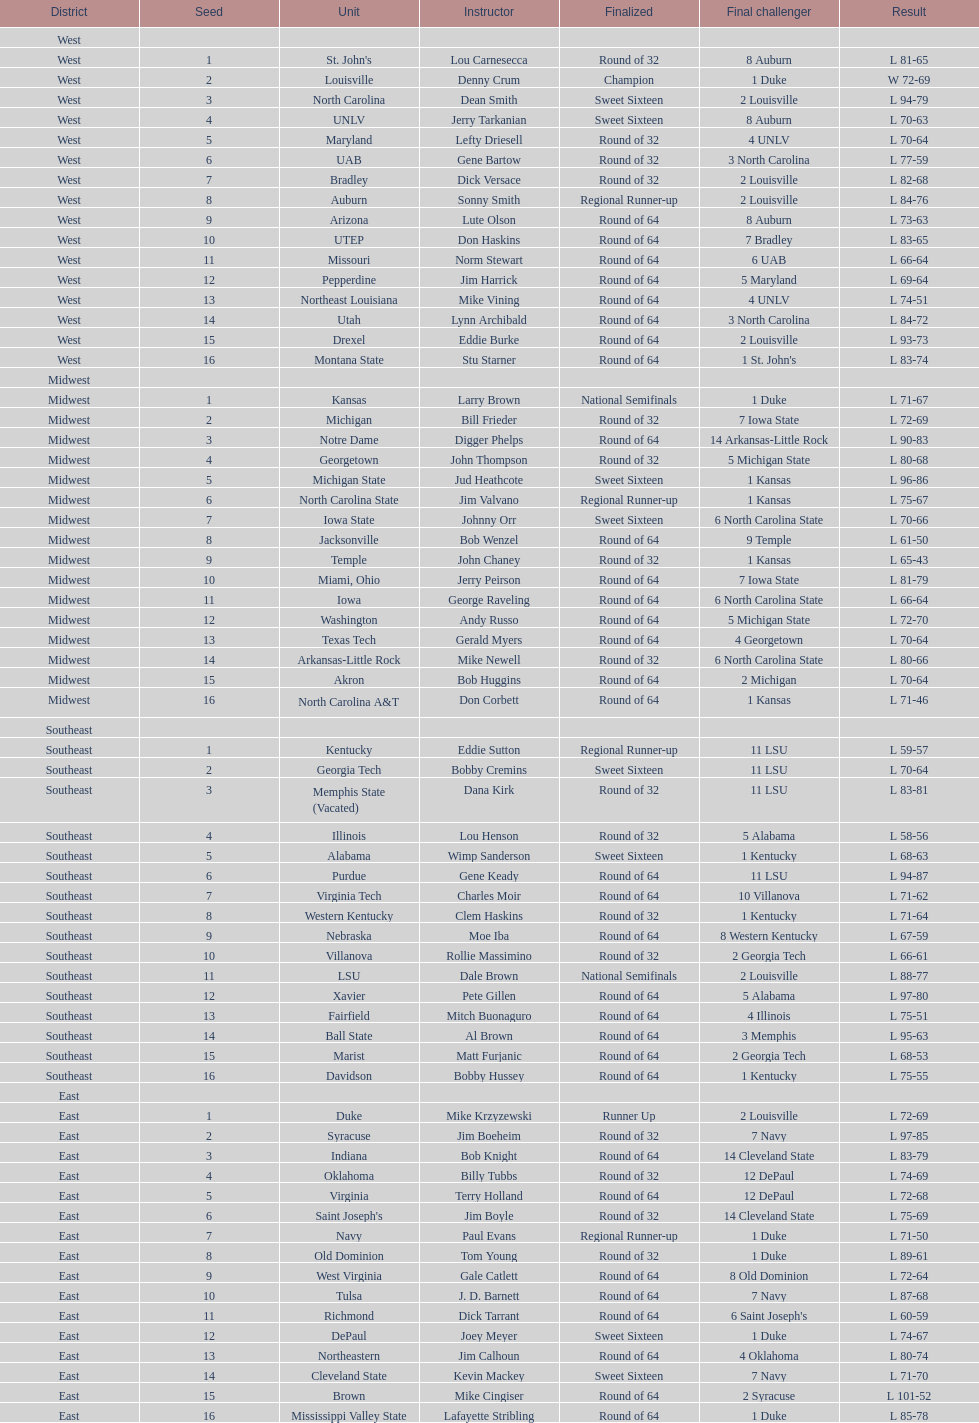Write the full table. {'header': ['District', 'Seed', 'Unit', 'Instructor', 'Finalized', 'Final challenger', 'Result'], 'rows': [['West', '', '', '', '', '', ''], ['West', '1', "St. John's", 'Lou Carnesecca', 'Round of 32', '8 Auburn', 'L 81-65'], ['West', '2', 'Louisville', 'Denny Crum', 'Champion', '1 Duke', 'W 72-69'], ['West', '3', 'North Carolina', 'Dean Smith', 'Sweet Sixteen', '2 Louisville', 'L 94-79'], ['West', '4', 'UNLV', 'Jerry Tarkanian', 'Sweet Sixteen', '8 Auburn', 'L 70-63'], ['West', '5', 'Maryland', 'Lefty Driesell', 'Round of 32', '4 UNLV', 'L 70-64'], ['West', '6', 'UAB', 'Gene Bartow', 'Round of 32', '3 North Carolina', 'L 77-59'], ['West', '7', 'Bradley', 'Dick Versace', 'Round of 32', '2 Louisville', 'L 82-68'], ['West', '8', 'Auburn', 'Sonny Smith', 'Regional Runner-up', '2 Louisville', 'L 84-76'], ['West', '9', 'Arizona', 'Lute Olson', 'Round of 64', '8 Auburn', 'L 73-63'], ['West', '10', 'UTEP', 'Don Haskins', 'Round of 64', '7 Bradley', 'L 83-65'], ['West', '11', 'Missouri', 'Norm Stewart', 'Round of 64', '6 UAB', 'L 66-64'], ['West', '12', 'Pepperdine', 'Jim Harrick', 'Round of 64', '5 Maryland', 'L 69-64'], ['West', '13', 'Northeast Louisiana', 'Mike Vining', 'Round of 64', '4 UNLV', 'L 74-51'], ['West', '14', 'Utah', 'Lynn Archibald', 'Round of 64', '3 North Carolina', 'L 84-72'], ['West', '15', 'Drexel', 'Eddie Burke', 'Round of 64', '2 Louisville', 'L 93-73'], ['West', '16', 'Montana State', 'Stu Starner', 'Round of 64', "1 St. John's", 'L 83-74'], ['Midwest', '', '', '', '', '', ''], ['Midwest', '1', 'Kansas', 'Larry Brown', 'National Semifinals', '1 Duke', 'L 71-67'], ['Midwest', '2', 'Michigan', 'Bill Frieder', 'Round of 32', '7 Iowa State', 'L 72-69'], ['Midwest', '3', 'Notre Dame', 'Digger Phelps', 'Round of 64', '14 Arkansas-Little Rock', 'L 90-83'], ['Midwest', '4', 'Georgetown', 'John Thompson', 'Round of 32', '5 Michigan State', 'L 80-68'], ['Midwest', '5', 'Michigan State', 'Jud Heathcote', 'Sweet Sixteen', '1 Kansas', 'L 96-86'], ['Midwest', '6', 'North Carolina State', 'Jim Valvano', 'Regional Runner-up', '1 Kansas', 'L 75-67'], ['Midwest', '7', 'Iowa State', 'Johnny Orr', 'Sweet Sixteen', '6 North Carolina State', 'L 70-66'], ['Midwest', '8', 'Jacksonville', 'Bob Wenzel', 'Round of 64', '9 Temple', 'L 61-50'], ['Midwest', '9', 'Temple', 'John Chaney', 'Round of 32', '1 Kansas', 'L 65-43'], ['Midwest', '10', 'Miami, Ohio', 'Jerry Peirson', 'Round of 64', '7 Iowa State', 'L 81-79'], ['Midwest', '11', 'Iowa', 'George Raveling', 'Round of 64', '6 North Carolina State', 'L 66-64'], ['Midwest', '12', 'Washington', 'Andy Russo', 'Round of 64', '5 Michigan State', 'L 72-70'], ['Midwest', '13', 'Texas Tech', 'Gerald Myers', 'Round of 64', '4 Georgetown', 'L 70-64'], ['Midwest', '14', 'Arkansas-Little Rock', 'Mike Newell', 'Round of 32', '6 North Carolina State', 'L 80-66'], ['Midwest', '15', 'Akron', 'Bob Huggins', 'Round of 64', '2 Michigan', 'L 70-64'], ['Midwest', '16', 'North Carolina A&T', 'Don Corbett', 'Round of 64', '1 Kansas', 'L 71-46'], ['Southeast', '', '', '', '', '', ''], ['Southeast', '1', 'Kentucky', 'Eddie Sutton', 'Regional Runner-up', '11 LSU', 'L 59-57'], ['Southeast', '2', 'Georgia Tech', 'Bobby Cremins', 'Sweet Sixteen', '11 LSU', 'L 70-64'], ['Southeast', '3', 'Memphis State (Vacated)', 'Dana Kirk', 'Round of 32', '11 LSU', 'L 83-81'], ['Southeast', '4', 'Illinois', 'Lou Henson', 'Round of 32', '5 Alabama', 'L 58-56'], ['Southeast', '5', 'Alabama', 'Wimp Sanderson', 'Sweet Sixteen', '1 Kentucky', 'L 68-63'], ['Southeast', '6', 'Purdue', 'Gene Keady', 'Round of 64', '11 LSU', 'L 94-87'], ['Southeast', '7', 'Virginia Tech', 'Charles Moir', 'Round of 64', '10 Villanova', 'L 71-62'], ['Southeast', '8', 'Western Kentucky', 'Clem Haskins', 'Round of 32', '1 Kentucky', 'L 71-64'], ['Southeast', '9', 'Nebraska', 'Moe Iba', 'Round of 64', '8 Western Kentucky', 'L 67-59'], ['Southeast', '10', 'Villanova', 'Rollie Massimino', 'Round of 32', '2 Georgia Tech', 'L 66-61'], ['Southeast', '11', 'LSU', 'Dale Brown', 'National Semifinals', '2 Louisville', 'L 88-77'], ['Southeast', '12', 'Xavier', 'Pete Gillen', 'Round of 64', '5 Alabama', 'L 97-80'], ['Southeast', '13', 'Fairfield', 'Mitch Buonaguro', 'Round of 64', '4 Illinois', 'L 75-51'], ['Southeast', '14', 'Ball State', 'Al Brown', 'Round of 64', '3 Memphis', 'L 95-63'], ['Southeast', '15', 'Marist', 'Matt Furjanic', 'Round of 64', '2 Georgia Tech', 'L 68-53'], ['Southeast', '16', 'Davidson', 'Bobby Hussey', 'Round of 64', '1 Kentucky', 'L 75-55'], ['East', '', '', '', '', '', ''], ['East', '1', 'Duke', 'Mike Krzyzewski', 'Runner Up', '2 Louisville', 'L 72-69'], ['East', '2', 'Syracuse', 'Jim Boeheim', 'Round of 32', '7 Navy', 'L 97-85'], ['East', '3', 'Indiana', 'Bob Knight', 'Round of 64', '14 Cleveland State', 'L 83-79'], ['East', '4', 'Oklahoma', 'Billy Tubbs', 'Round of 32', '12 DePaul', 'L 74-69'], ['East', '5', 'Virginia', 'Terry Holland', 'Round of 64', '12 DePaul', 'L 72-68'], ['East', '6', "Saint Joseph's", 'Jim Boyle', 'Round of 32', '14 Cleveland State', 'L 75-69'], ['East', '7', 'Navy', 'Paul Evans', 'Regional Runner-up', '1 Duke', 'L 71-50'], ['East', '8', 'Old Dominion', 'Tom Young', 'Round of 32', '1 Duke', 'L 89-61'], ['East', '9', 'West Virginia', 'Gale Catlett', 'Round of 64', '8 Old Dominion', 'L 72-64'], ['East', '10', 'Tulsa', 'J. D. Barnett', 'Round of 64', '7 Navy', 'L 87-68'], ['East', '11', 'Richmond', 'Dick Tarrant', 'Round of 64', "6 Saint Joseph's", 'L 60-59'], ['East', '12', 'DePaul', 'Joey Meyer', 'Sweet Sixteen', '1 Duke', 'L 74-67'], ['East', '13', 'Northeastern', 'Jim Calhoun', 'Round of 64', '4 Oklahoma', 'L 80-74'], ['East', '14', 'Cleveland State', 'Kevin Mackey', 'Sweet Sixteen', '7 Navy', 'L 71-70'], ['East', '15', 'Brown', 'Mike Cingiser', 'Round of 64', '2 Syracuse', 'L 101-52'], ['East', '16', 'Mississippi Valley State', 'Lafayette Stribling', 'Round of 64', '1 Duke', 'L 85-78']]} Who was the only champion? Louisville. 